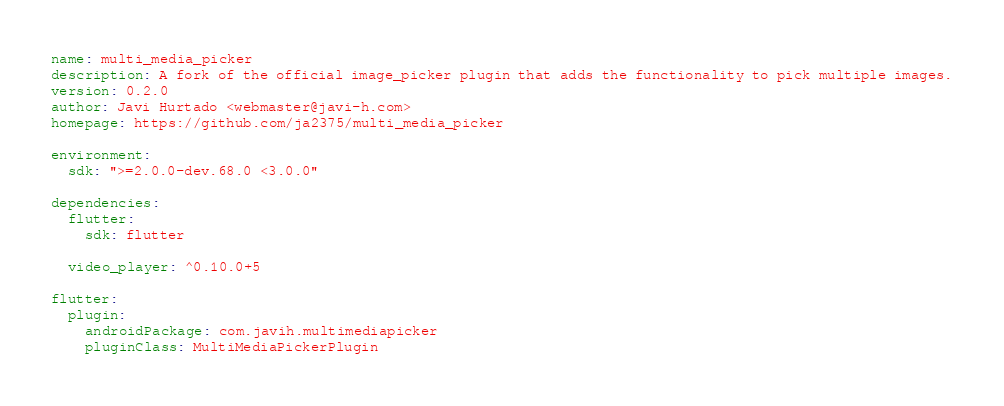Convert code to text. <code><loc_0><loc_0><loc_500><loc_500><_YAML_>name: multi_media_picker
description: A fork of the official image_picker plugin that adds the functionality to pick multiple images.
version: 0.2.0
author: Javi Hurtado <webmaster@javi-h.com>
homepage: https://github.com/ja2375/multi_media_picker

environment:
  sdk: ">=2.0.0-dev.68.0 <3.0.0"

dependencies:
  flutter:
    sdk: flutter

  video_player: ^0.10.0+5

flutter:
  plugin:
    androidPackage: com.javih.multimediapicker
    pluginClass: MultiMediaPickerPlugin
</code> 